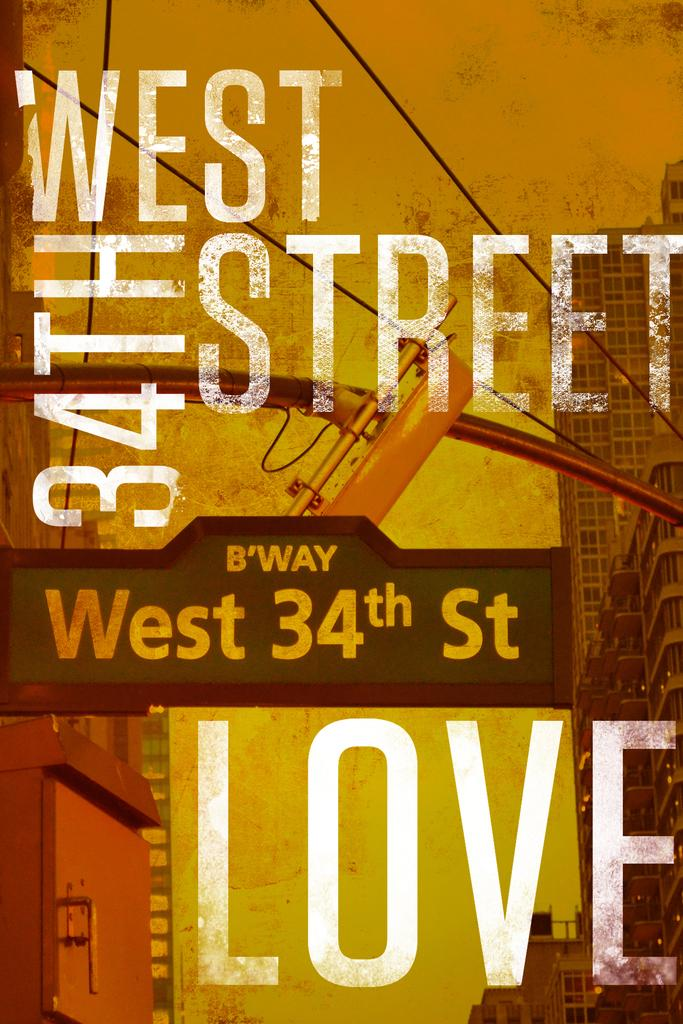<image>
Give a short and clear explanation of the subsequent image. A poster with West 34th street on the front. 